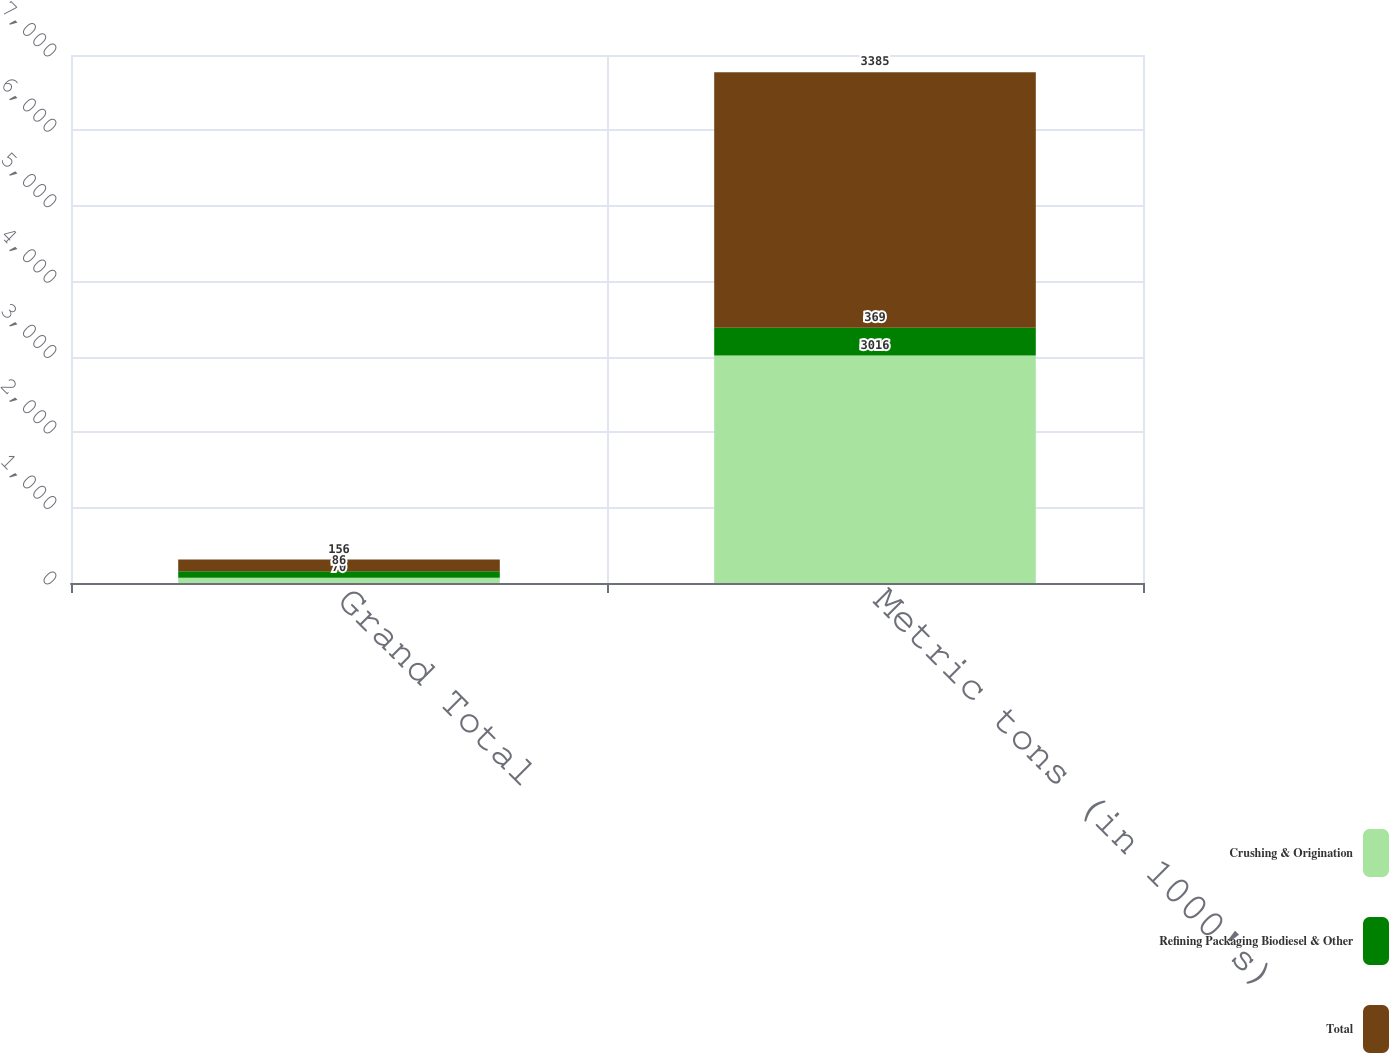Convert chart to OTSL. <chart><loc_0><loc_0><loc_500><loc_500><stacked_bar_chart><ecel><fcel>Grand Total<fcel>Metric tons (in 1000's)<nl><fcel>Crushing & Origination<fcel>70<fcel>3016<nl><fcel>Refining Packaging Biodiesel & Other<fcel>86<fcel>369<nl><fcel>Total<fcel>156<fcel>3385<nl></chart> 